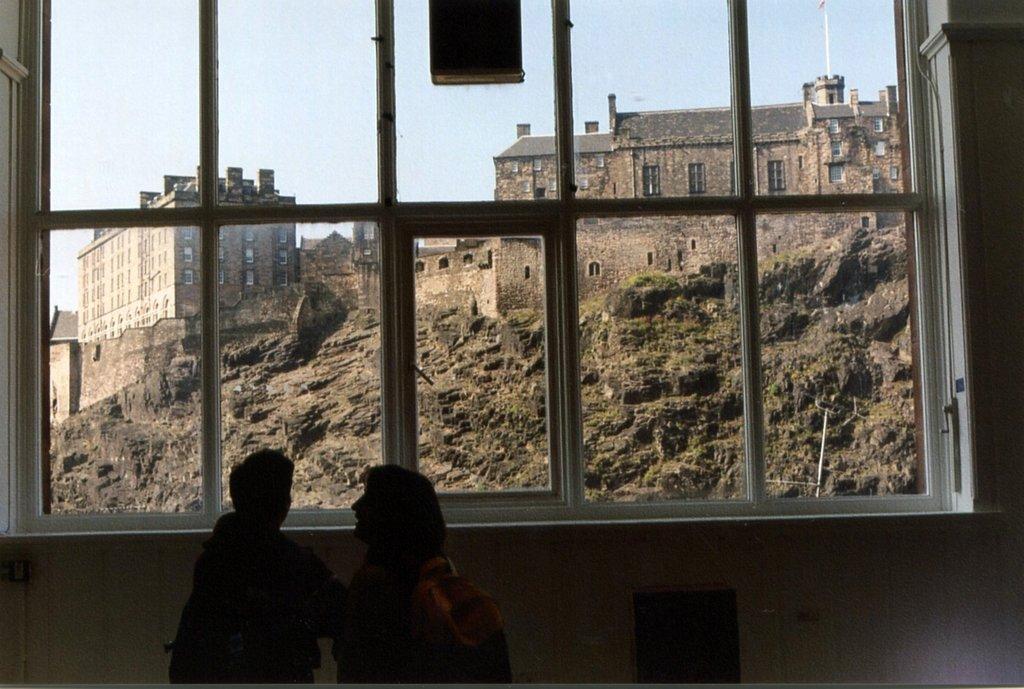Can you describe this image briefly? In they image in the center there is a wall,glass window and two persons were standing. Through glass window,we can see the sky,buildings,windows,rood,wall etc. 